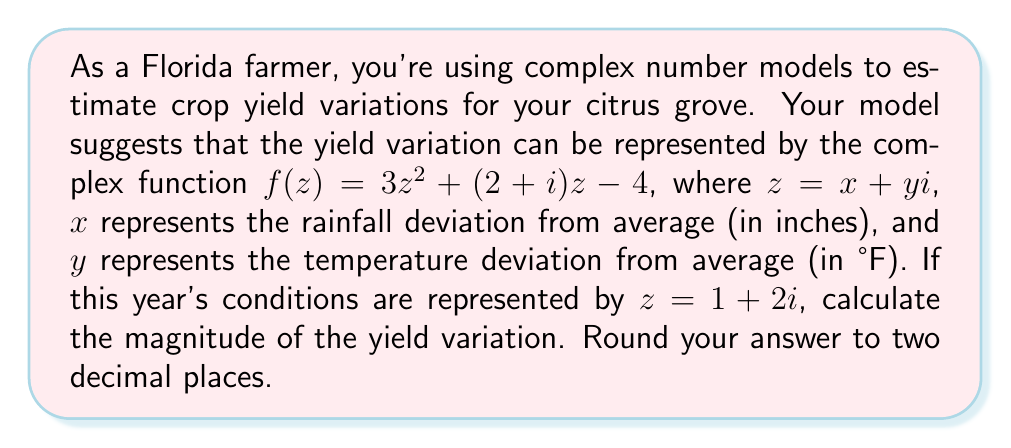Can you answer this question? To solve this problem, we'll follow these steps:

1) First, we need to calculate $f(z)$ for $z = 1 + 2i$:

   $f(z) = 3z^2 + (2+i)z - 4$
   
   $f(1+2i) = 3(1+2i)^2 + (2+i)(1+2i) - 4$

2) Let's expand $(1+2i)^2$:
   
   $(1+2i)^2 = 1 + 4i + 4i^2 = 1 + 4i - 4 = -3 + 4i$

3) Now we can calculate $f(1+2i)$:

   $f(1+2i) = 3(-3+4i) + (2+i)(1+2i) - 4$
   
   $= -9 + 12i + (2+i)(1+2i) - 4$
   
   $= -9 + 12i + (2+2i+i+2i^2) - 4$
   
   $= -9 + 12i + (2+3i-2) - 4$
   
   $= -9 + 12i + 3i - 6$
   
   $= -15 + 15i$

4) The magnitude of a complex number $a + bi$ is given by $\sqrt{a^2 + b^2}$. In this case:

   $|f(1+2i)| = \sqrt{(-15)^2 + 15^2}$
   
   $= \sqrt{225 + 225}$
   
   $= \sqrt{450}$
   
   $\approx 21.21$

5) Rounding to two decimal places, we get 21.21.

This magnitude represents the overall intensity of the yield variation, combining the effects of both rainfall and temperature deviations.
Answer: 21.21 